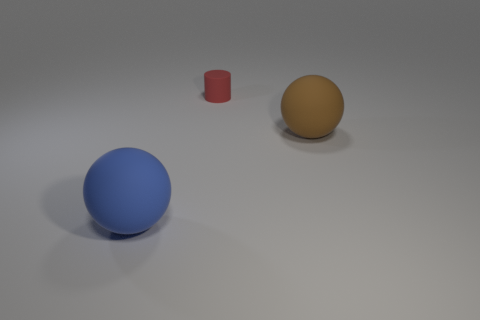Add 1 tiny red matte cylinders. How many objects exist? 4 Subtract all spheres. How many objects are left? 1 Subtract all big brown matte spheres. Subtract all red matte cylinders. How many objects are left? 1 Add 1 large brown matte things. How many large brown matte things are left? 2 Add 2 large brown cubes. How many large brown cubes exist? 2 Subtract 0 green balls. How many objects are left? 3 